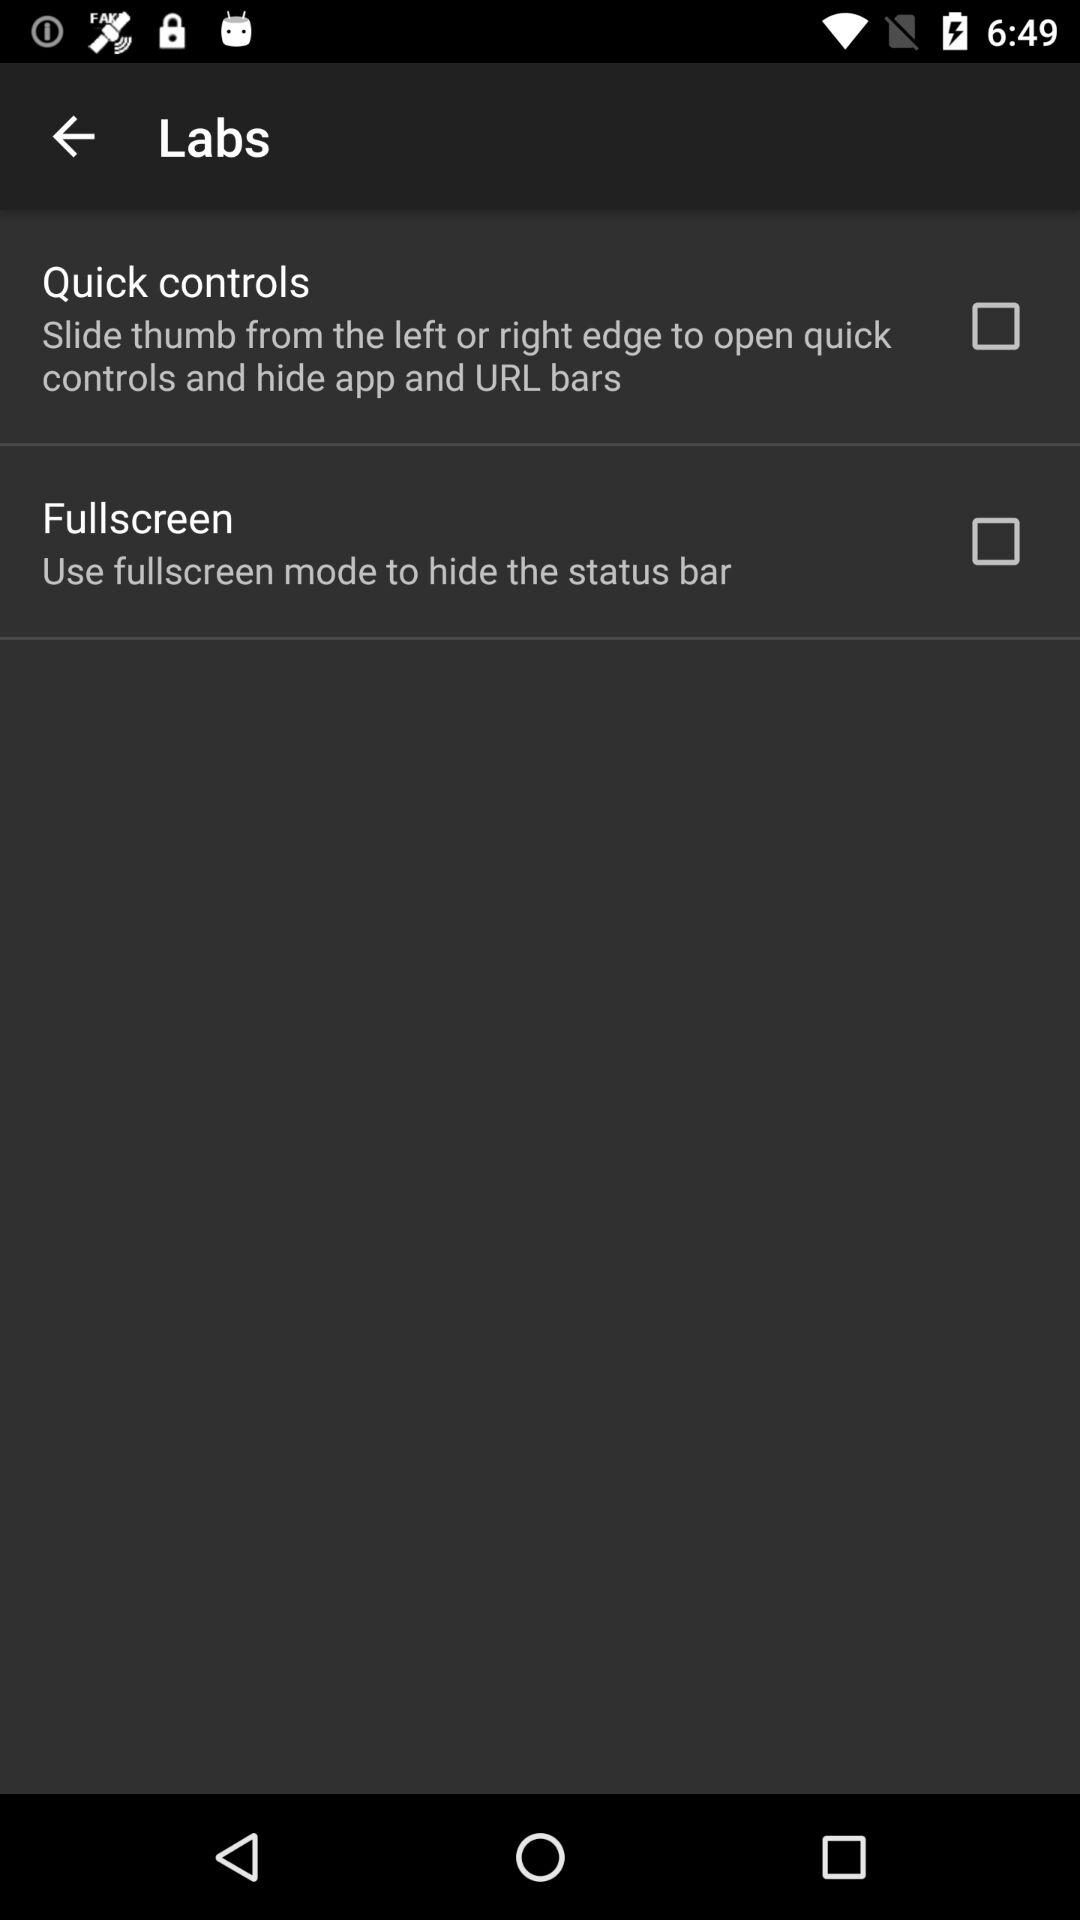What is the status of the quick control? The status is off. 